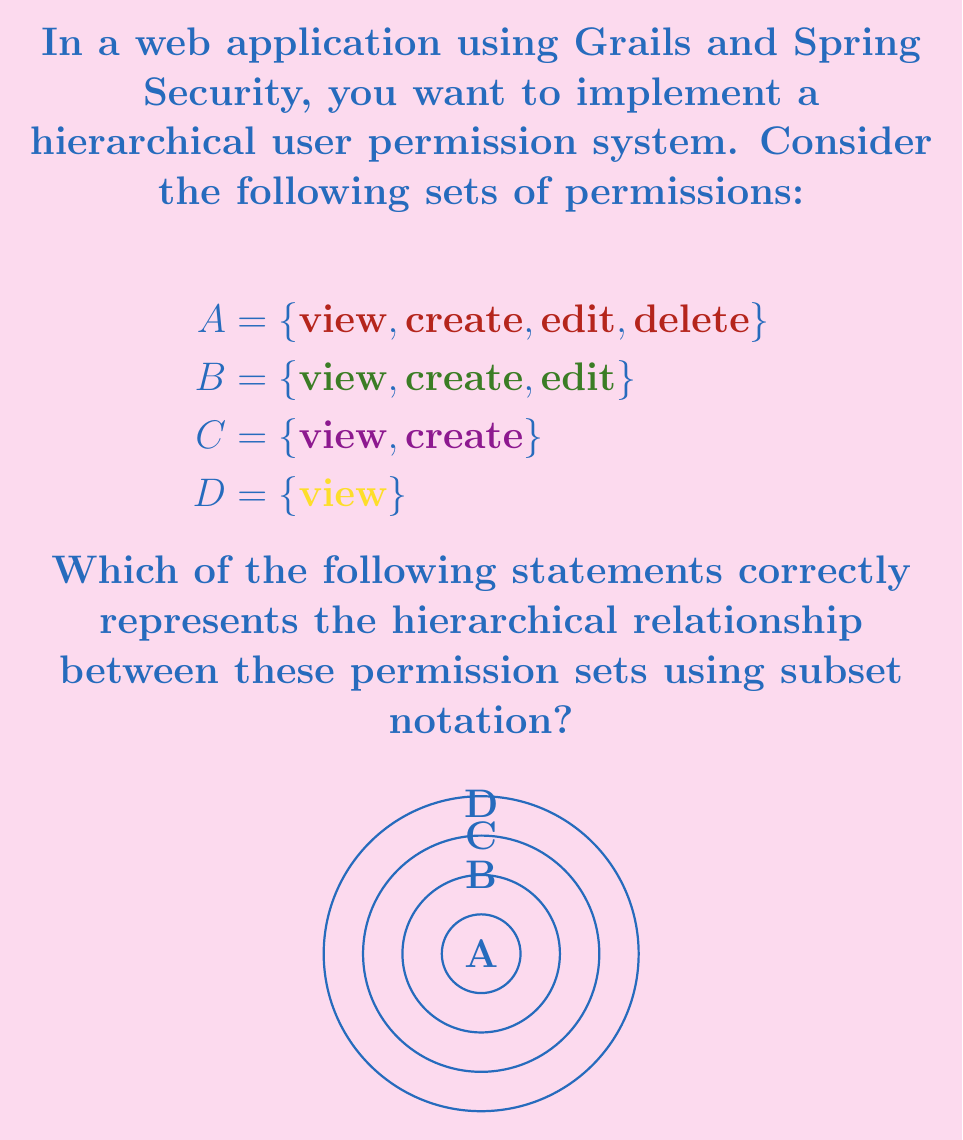Show me your answer to this math problem. To model hierarchical user permissions using subsets, we need to understand that each inner set is a subset of the outer sets. Let's break this down step-by-step:

1. First, let's examine set D:
   $D = \{\text{view}\}$
   This is the most basic permission set.

2. Now, let's look at set C:
   $C = \{\text{view}, \text{create}\}$
   We can see that D is a subset of C, as all elements in D are also in C.

3. Next, set B:
   $B = \{\text{view}, \text{create}, \text{edit}\}$
   We can observe that C is a subset of B, and consequently, D is also a subset of B.

4. Finally, set A:
   $A = \{\text{view}, \text{create}, \text{edit}, \text{delete}\}$
   A contains all the elements from the other sets, making B, C, and D subsets of A.

5. To represent this hierarchical relationship using subset notation, we can write:

   $D \subset C \subset B \subset A$

This notation shows that each set is a proper subset of the sets to its right, representing a clear hierarchy of permissions where each level includes all the permissions of the levels below it plus additional permissions.
Answer: $D \subset C \subset B \subset A$ 